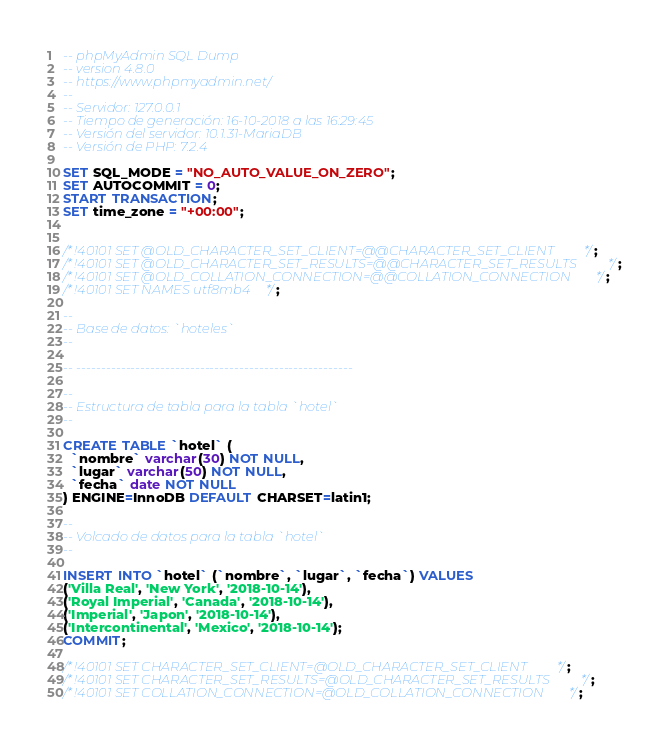Convert code to text. <code><loc_0><loc_0><loc_500><loc_500><_SQL_>-- phpMyAdmin SQL Dump
-- version 4.8.0
-- https://www.phpmyadmin.net/
--
-- Servidor: 127.0.0.1
-- Tiempo de generación: 16-10-2018 a las 16:29:45
-- Versión del servidor: 10.1.31-MariaDB
-- Versión de PHP: 7.2.4

SET SQL_MODE = "NO_AUTO_VALUE_ON_ZERO";
SET AUTOCOMMIT = 0;
START TRANSACTION;
SET time_zone = "+00:00";


/*!40101 SET @OLD_CHARACTER_SET_CLIENT=@@CHARACTER_SET_CLIENT */;
/*!40101 SET @OLD_CHARACTER_SET_RESULTS=@@CHARACTER_SET_RESULTS */;
/*!40101 SET @OLD_COLLATION_CONNECTION=@@COLLATION_CONNECTION */;
/*!40101 SET NAMES utf8mb4 */;

--
-- Base de datos: `hoteles`
--

-- --------------------------------------------------------

--
-- Estructura de tabla para la tabla `hotel`
--

CREATE TABLE `hotel` (
  `nombre` varchar(30) NOT NULL,
  `lugar` varchar(50) NOT NULL,
  `fecha` date NOT NULL
) ENGINE=InnoDB DEFAULT CHARSET=latin1;

--
-- Volcado de datos para la tabla `hotel`
--

INSERT INTO `hotel` (`nombre`, `lugar`, `fecha`) VALUES
('Villa Real', 'New York', '2018-10-14'),
('Royal Imperial', 'Canada', '2018-10-14'),
('Imperial', 'Japon', '2018-10-14'),
('Intercontinental', 'Mexico', '2018-10-14');
COMMIT;

/*!40101 SET CHARACTER_SET_CLIENT=@OLD_CHARACTER_SET_CLIENT */;
/*!40101 SET CHARACTER_SET_RESULTS=@OLD_CHARACTER_SET_RESULTS */;
/*!40101 SET COLLATION_CONNECTION=@OLD_COLLATION_CONNECTION */;
</code> 